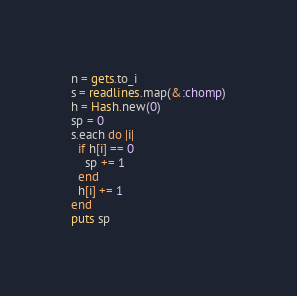<code> <loc_0><loc_0><loc_500><loc_500><_Ruby_>n = gets.to_i
s = readlines.map(&:chomp)
h = Hash.new(0)
sp = 0
s.each do |i|
  if h[i] == 0
    sp += 1
  end
  h[i] += 1
end
puts sp</code> 